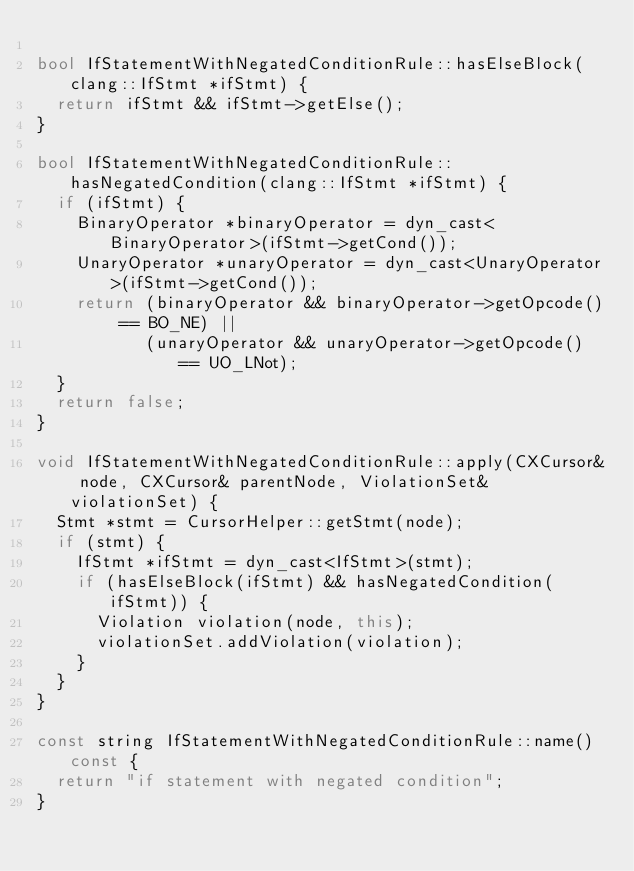Convert code to text. <code><loc_0><loc_0><loc_500><loc_500><_C++_>
bool IfStatementWithNegatedConditionRule::hasElseBlock(clang::IfStmt *ifStmt) {
  return ifStmt && ifStmt->getElse();
}

bool IfStatementWithNegatedConditionRule::hasNegatedCondition(clang::IfStmt *ifStmt) {
  if (ifStmt) {
    BinaryOperator *binaryOperator = dyn_cast<BinaryOperator>(ifStmt->getCond());
    UnaryOperator *unaryOperator = dyn_cast<UnaryOperator>(ifStmt->getCond());
    return (binaryOperator && binaryOperator->getOpcode() == BO_NE) ||
           (unaryOperator && unaryOperator->getOpcode() == UO_LNot);
  }
  return false;
}

void IfStatementWithNegatedConditionRule::apply(CXCursor& node, CXCursor& parentNode, ViolationSet& violationSet) {
  Stmt *stmt = CursorHelper::getStmt(node);
  if (stmt) {
    IfStmt *ifStmt = dyn_cast<IfStmt>(stmt);
    if (hasElseBlock(ifStmt) && hasNegatedCondition(ifStmt)) {
      Violation violation(node, this);
      violationSet.addViolation(violation);
    }
  }
}

const string IfStatementWithNegatedConditionRule::name() const {
  return "if statement with negated condition";
}
</code> 